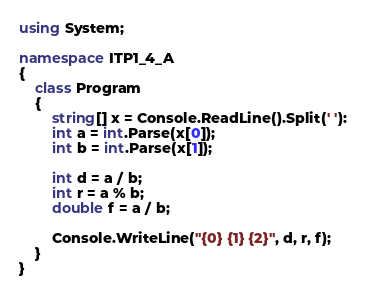Convert code to text. <code><loc_0><loc_0><loc_500><loc_500><_C#_>using System;

namespace ITP1_4_A
{
    class Program
    {
        string[] x = Console.ReadLine().Split(' '):
        int a = int.Parse(x[0]);
        int b = int.Parse(x[1]);
        
        int d = a / b;
        int r = a % b;
        double f = a / b;
        
        Console.WriteLine("{0} {1} {2}", d, r, f);
    }
}
</code> 